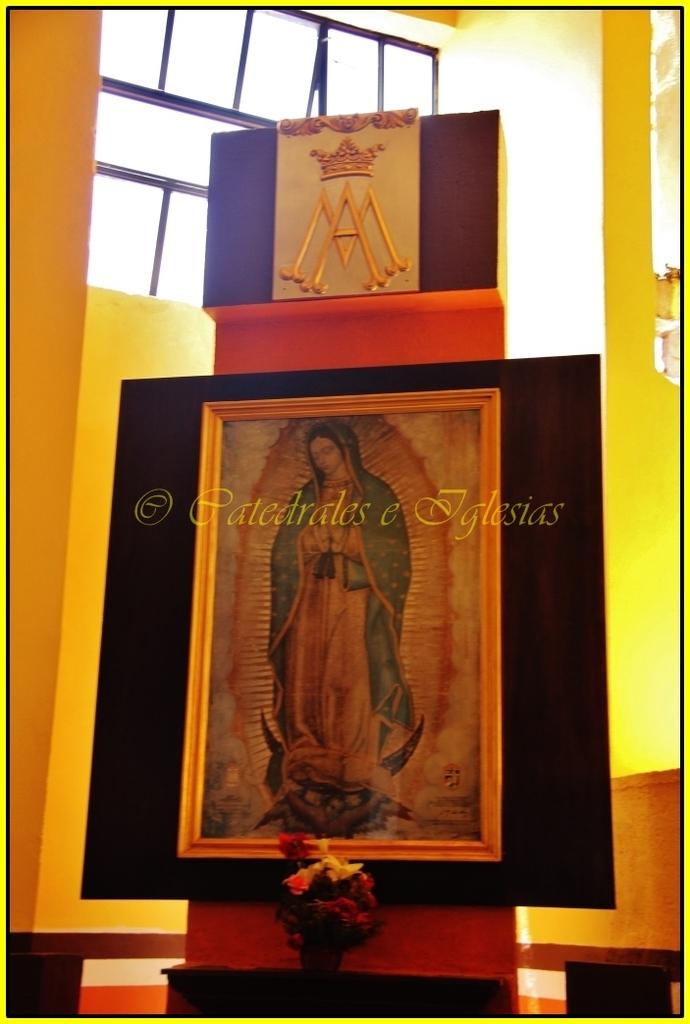What color are the flowers under the piece of art?
Offer a very short reply. Answering does not require reading text in the image. 